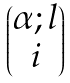<formula> <loc_0><loc_0><loc_500><loc_500>\begin{pmatrix} \alpha ; l \\ i \\ \end{pmatrix}</formula> 